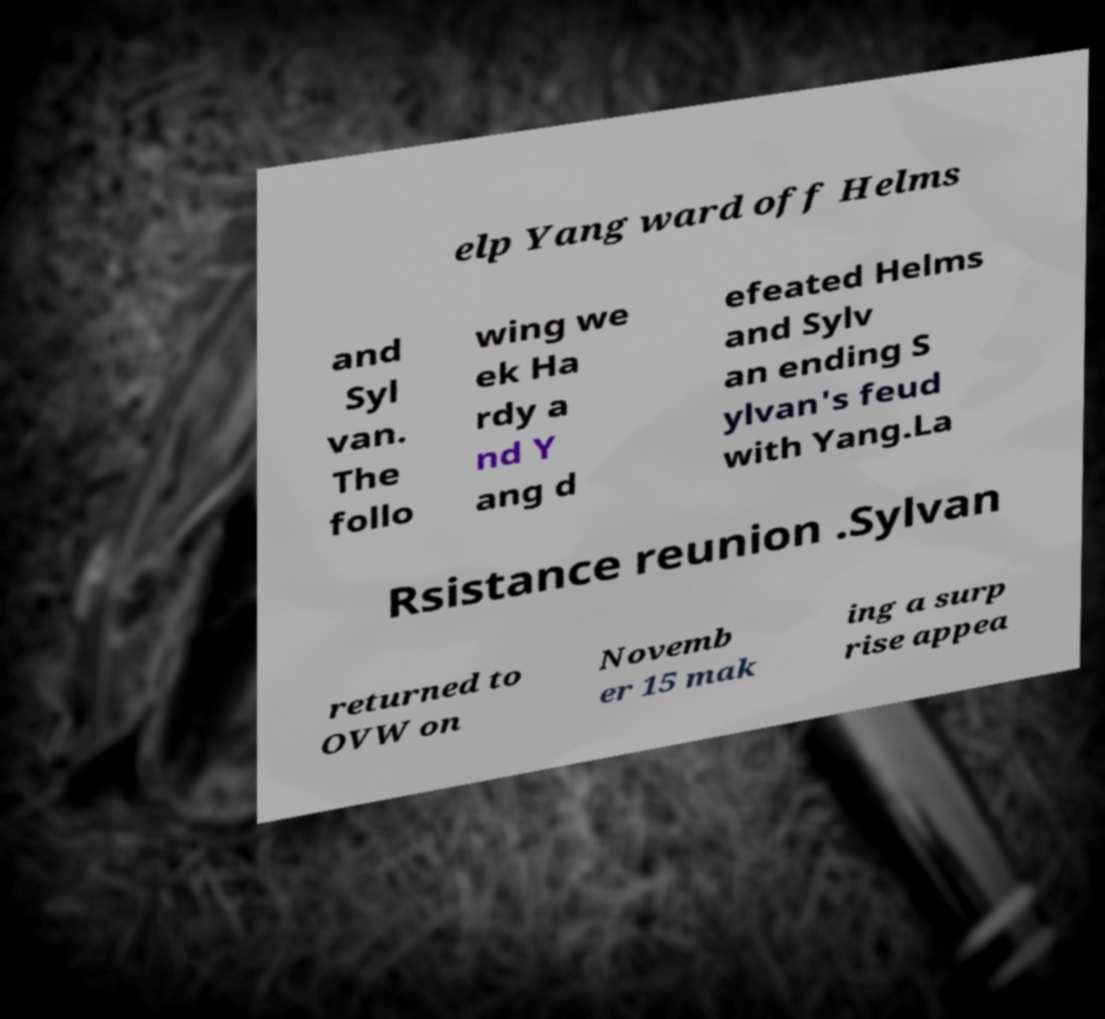What messages or text are displayed in this image? I need them in a readable, typed format. elp Yang ward off Helms and Syl van. The follo wing we ek Ha rdy a nd Y ang d efeated Helms and Sylv an ending S ylvan's feud with Yang.La Rsistance reunion .Sylvan returned to OVW on Novemb er 15 mak ing a surp rise appea 